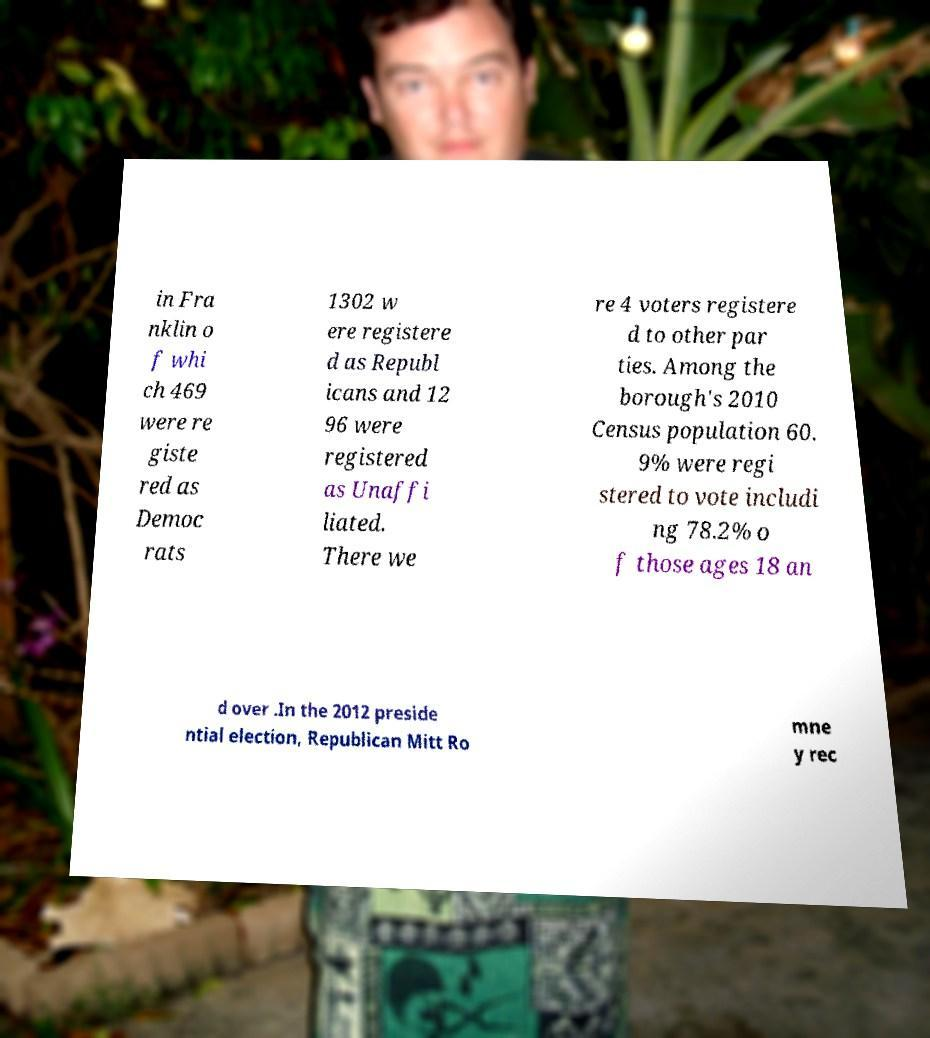Could you assist in decoding the text presented in this image and type it out clearly? in Fra nklin o f whi ch 469 were re giste red as Democ rats 1302 w ere registere d as Republ icans and 12 96 were registered as Unaffi liated. There we re 4 voters registere d to other par ties. Among the borough's 2010 Census population 60. 9% were regi stered to vote includi ng 78.2% o f those ages 18 an d over .In the 2012 preside ntial election, Republican Mitt Ro mne y rec 